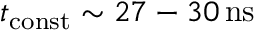<formula> <loc_0><loc_0><loc_500><loc_500>t _ { c o n s t } \sim 2 7 - 3 0 \, n s</formula> 